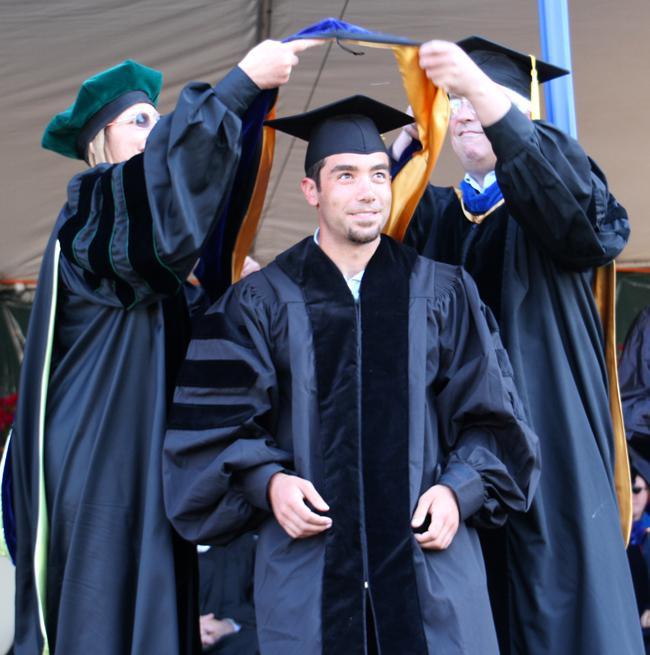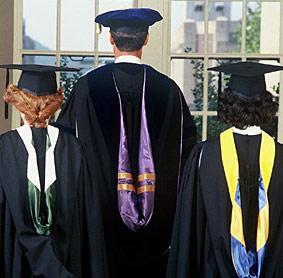The first image is the image on the left, the second image is the image on the right. For the images shown, is this caption "There are two people in every image wearing graduation caps." true? Answer yes or no. No. The first image is the image on the left, the second image is the image on the right. Examine the images to the left and right. Is the description "An image of a group of graduates includes a female with red hair and back turned to the camera." accurate? Answer yes or no. Yes. 